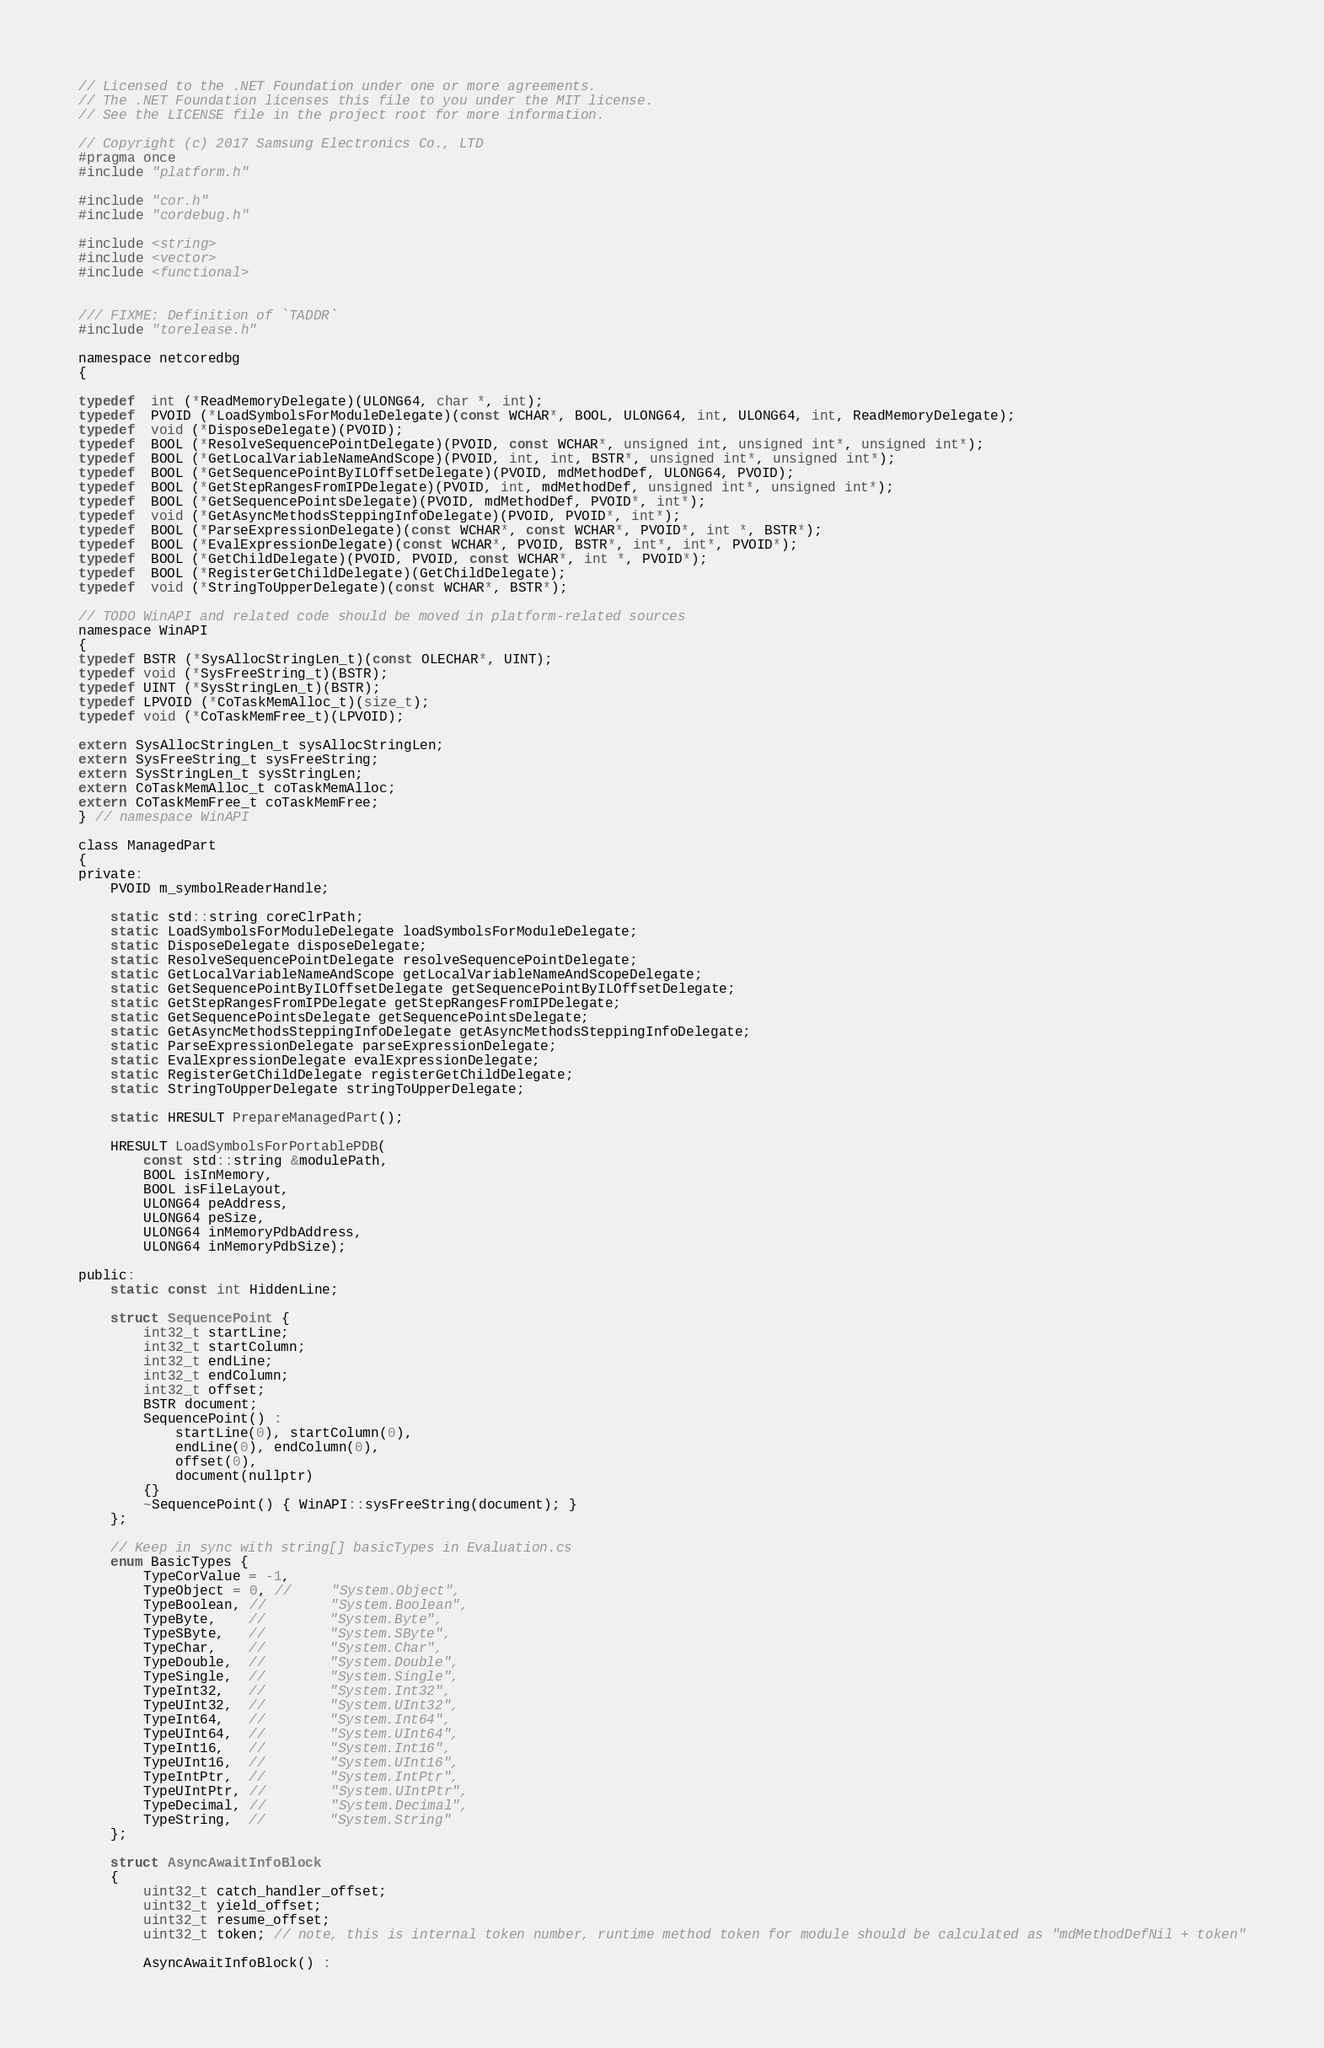<code> <loc_0><loc_0><loc_500><loc_500><_C_>// Licensed to the .NET Foundation under one or more agreements.
// The .NET Foundation licenses this file to you under the MIT license.
// See the LICENSE file in the project root for more information.

// Copyright (c) 2017 Samsung Electronics Co., LTD
#pragma once
#include "platform.h"

#include "cor.h"
#include "cordebug.h"

#include <string>
#include <vector>
#include <functional>


/// FIXME: Definition of `TADDR`
#include "torelease.h"

namespace netcoredbg
{

typedef  int (*ReadMemoryDelegate)(ULONG64, char *, int);
typedef  PVOID (*LoadSymbolsForModuleDelegate)(const WCHAR*, BOOL, ULONG64, int, ULONG64, int, ReadMemoryDelegate);
typedef  void (*DisposeDelegate)(PVOID);
typedef  BOOL (*ResolveSequencePointDelegate)(PVOID, const WCHAR*, unsigned int, unsigned int*, unsigned int*);
typedef  BOOL (*GetLocalVariableNameAndScope)(PVOID, int, int, BSTR*, unsigned int*, unsigned int*);
typedef  BOOL (*GetSequencePointByILOffsetDelegate)(PVOID, mdMethodDef, ULONG64, PVOID);
typedef  BOOL (*GetStepRangesFromIPDelegate)(PVOID, int, mdMethodDef, unsigned int*, unsigned int*);
typedef  BOOL (*GetSequencePointsDelegate)(PVOID, mdMethodDef, PVOID*, int*);
typedef  void (*GetAsyncMethodsSteppingInfoDelegate)(PVOID, PVOID*, int*);
typedef  BOOL (*ParseExpressionDelegate)(const WCHAR*, const WCHAR*, PVOID*, int *, BSTR*);
typedef  BOOL (*EvalExpressionDelegate)(const WCHAR*, PVOID, BSTR*, int*, int*, PVOID*);
typedef  BOOL (*GetChildDelegate)(PVOID, PVOID, const WCHAR*, int *, PVOID*);
typedef  BOOL (*RegisterGetChildDelegate)(GetChildDelegate);
typedef  void (*StringToUpperDelegate)(const WCHAR*, BSTR*);

// TODO WinAPI and related code should be moved in platform-related sources
namespace WinAPI
{
typedef BSTR (*SysAllocStringLen_t)(const OLECHAR*, UINT);
typedef void (*SysFreeString_t)(BSTR);
typedef UINT (*SysStringLen_t)(BSTR);
typedef LPVOID (*CoTaskMemAlloc_t)(size_t);
typedef void (*CoTaskMemFree_t)(LPVOID);

extern SysAllocStringLen_t sysAllocStringLen;
extern SysFreeString_t sysFreeString;
extern SysStringLen_t sysStringLen;
extern CoTaskMemAlloc_t coTaskMemAlloc;
extern CoTaskMemFree_t coTaskMemFree;
} // namespace WinAPI

class ManagedPart
{
private:
    PVOID m_symbolReaderHandle;

    static std::string coreClrPath;
    static LoadSymbolsForModuleDelegate loadSymbolsForModuleDelegate;
    static DisposeDelegate disposeDelegate;
    static ResolveSequencePointDelegate resolveSequencePointDelegate;
    static GetLocalVariableNameAndScope getLocalVariableNameAndScopeDelegate;
    static GetSequencePointByILOffsetDelegate getSequencePointByILOffsetDelegate;
    static GetStepRangesFromIPDelegate getStepRangesFromIPDelegate;
    static GetSequencePointsDelegate getSequencePointsDelegate;
    static GetAsyncMethodsSteppingInfoDelegate getAsyncMethodsSteppingInfoDelegate;
    static ParseExpressionDelegate parseExpressionDelegate;
    static EvalExpressionDelegate evalExpressionDelegate;
    static RegisterGetChildDelegate registerGetChildDelegate;
    static StringToUpperDelegate stringToUpperDelegate;

    static HRESULT PrepareManagedPart();

    HRESULT LoadSymbolsForPortablePDB(
        const std::string &modulePath,
        BOOL isInMemory,
        BOOL isFileLayout,
        ULONG64 peAddress,
        ULONG64 peSize,
        ULONG64 inMemoryPdbAddress,
        ULONG64 inMemoryPdbSize);

public:
    static const int HiddenLine;

    struct SequencePoint {
        int32_t startLine;
        int32_t startColumn;
        int32_t endLine;
        int32_t endColumn;
        int32_t offset;
        BSTR document;
        SequencePoint() :
            startLine(0), startColumn(0),
            endLine(0), endColumn(0),
            offset(0),
            document(nullptr)
        {}
        ~SequencePoint() { WinAPI::sysFreeString(document); }
    };

    // Keep in sync with string[] basicTypes in Evaluation.cs
    enum BasicTypes {
        TypeCorValue = -1,
        TypeObject = 0, //     "System.Object",
        TypeBoolean, //        "System.Boolean",
        TypeByte,    //        "System.Byte",
        TypeSByte,   //        "System.SByte",
        TypeChar,    //        "System.Char",
        TypeDouble,  //        "System.Double",
        TypeSingle,  //        "System.Single",
        TypeInt32,   //        "System.Int32",
        TypeUInt32,  //        "System.UInt32",
        TypeInt64,   //        "System.Int64",
        TypeUInt64,  //        "System.UInt64",
        TypeInt16,   //        "System.Int16",
        TypeUInt16,  //        "System.UInt16",
        TypeIntPtr,  //        "System.IntPtr",
        TypeUIntPtr, //        "System.UIntPtr",
        TypeDecimal, //        "System.Decimal",
        TypeString,  //        "System.String"
    };

    struct AsyncAwaitInfoBlock
    {
        uint32_t catch_handler_offset;
        uint32_t yield_offset;
        uint32_t resume_offset;
        uint32_t token; // note, this is internal token number, runtime method token for module should be calculated as "mdMethodDefNil + token"
        
        AsyncAwaitInfoBlock() :</code> 